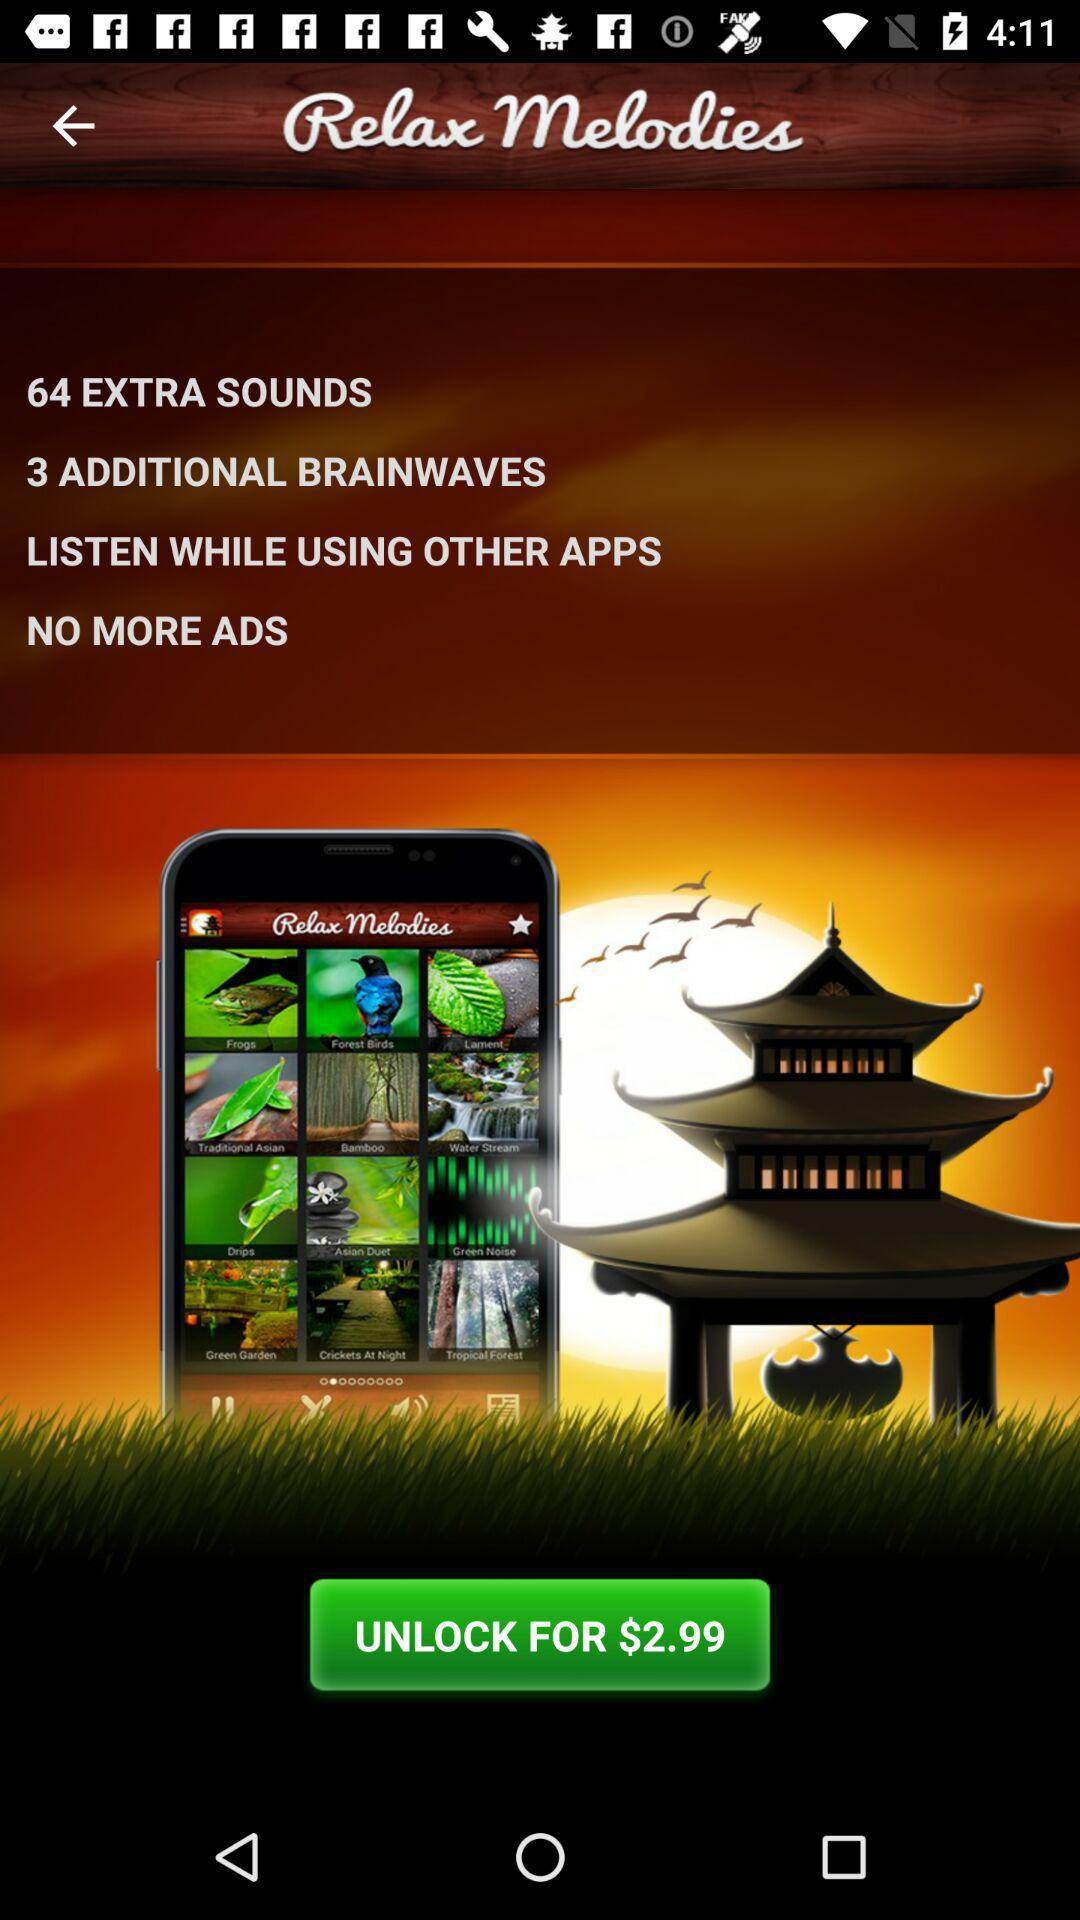Who is this application powered by?
When the provided information is insufficient, respond with <no answer>. <no answer> 